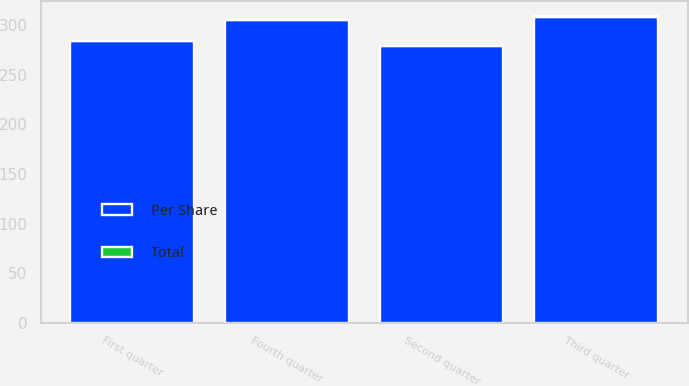<chart> <loc_0><loc_0><loc_500><loc_500><stacked_bar_chart><ecel><fcel>First quarter<fcel>Second quarter<fcel>Third quarter<fcel>Fourth quarter<nl><fcel>Total<fcel>0.17<fcel>0.17<fcel>0.19<fcel>0.19<nl><fcel>Per Share<fcel>284<fcel>279<fcel>309<fcel>305<nl></chart> 